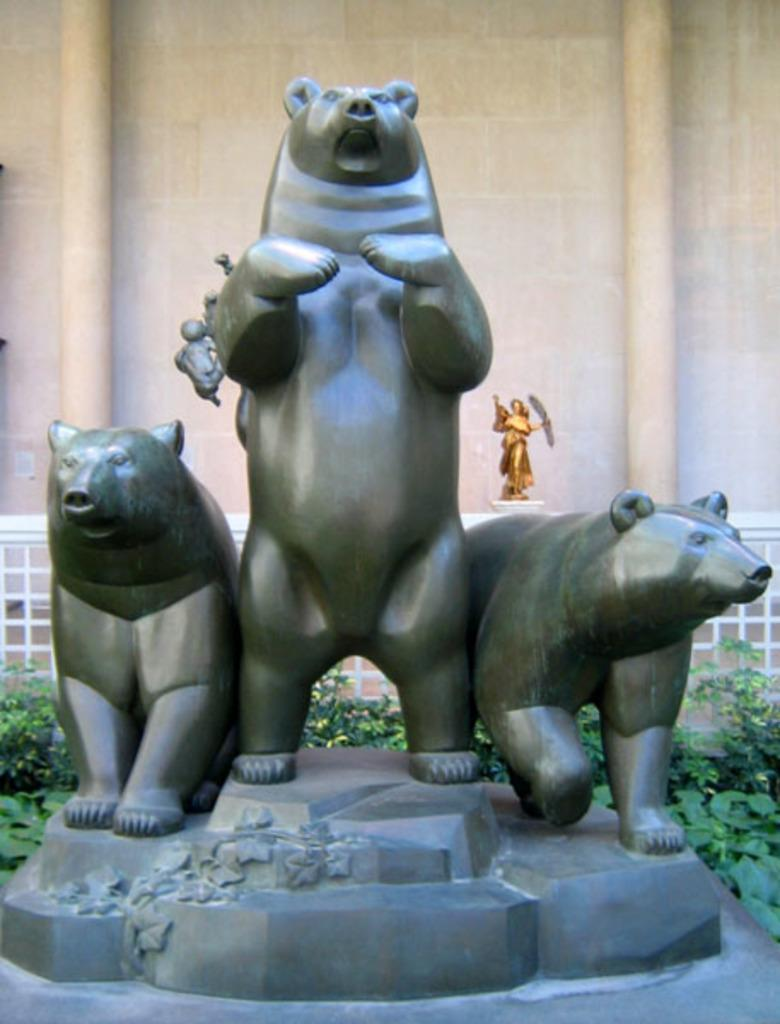What type of objects are depicted as statues in the image? There are statues of animals in the image. What can be seen in the background of the image? There are plants and a railing in the background of the image. Can you describe the statue of a person in the image? There is a statue of a person in-front of a building in the image. How many cats are sitting on the statue of a person in the image? There are no cats present on the statue of a person or anywhere else in the image. 